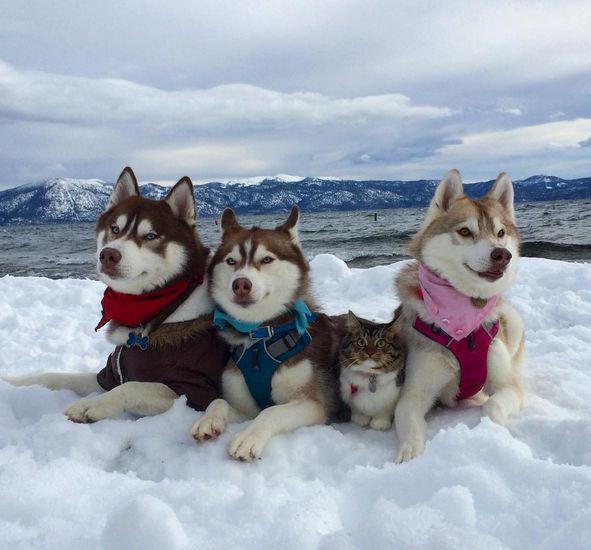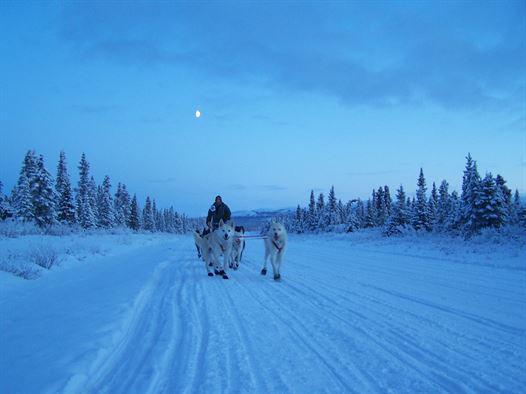The first image is the image on the left, the second image is the image on the right. Given the left and right images, does the statement "One photo contains a single dog." hold true? Answer yes or no. No. The first image is the image on the left, the second image is the image on the right. Given the left and right images, does the statement "An image shows just one dog, which is wearing a harness." hold true? Answer yes or no. No. 